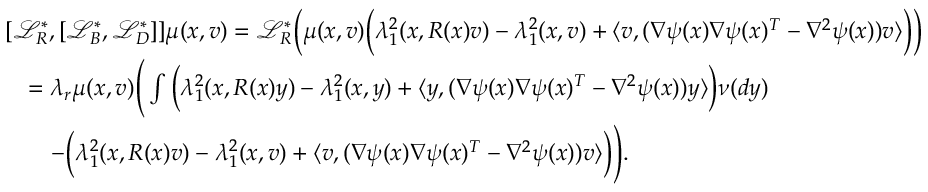<formula> <loc_0><loc_0><loc_500><loc_500>\begin{array} { r l } & { [ \mathcal { L } _ { R } ^ { * } , [ \mathcal { L } _ { B } ^ { * } , \mathcal { L } _ { D } ^ { * } ] ] \mu ( x , v ) = \mathcal { L } _ { R } ^ { * } \left ( \mu ( x , v ) \left ( \lambda _ { 1 } ^ { 2 } ( x , R ( x ) v ) - \lambda _ { 1 } ^ { 2 } ( x , v ) + \langle v , ( \nabla \psi ( x ) \nabla \psi ( x ) ^ { T } - \nabla ^ { 2 } \psi ( x ) ) v \rangle \right ) \right ) } \\ & { \quad = \lambda _ { r } \mu ( x , v ) \left ( \int \left ( \lambda _ { 1 } ^ { 2 } ( x , R ( x ) y ) - \lambda _ { 1 } ^ { 2 } ( x , y ) + \langle y , ( \nabla \psi ( x ) \nabla \psi ( x ) ^ { T } - \nabla ^ { 2 } \psi ( x ) ) y \rangle \right ) \nu ( d y ) } \\ & { \quad - \left ( \lambda _ { 1 } ^ { 2 } ( x , R ( x ) v ) - \lambda _ { 1 } ^ { 2 } ( x , v ) + \langle v , ( \nabla \psi ( x ) \nabla \psi ( x ) ^ { T } - \nabla ^ { 2 } \psi ( x ) ) v \rangle \right ) \right ) . } \end{array}</formula> 